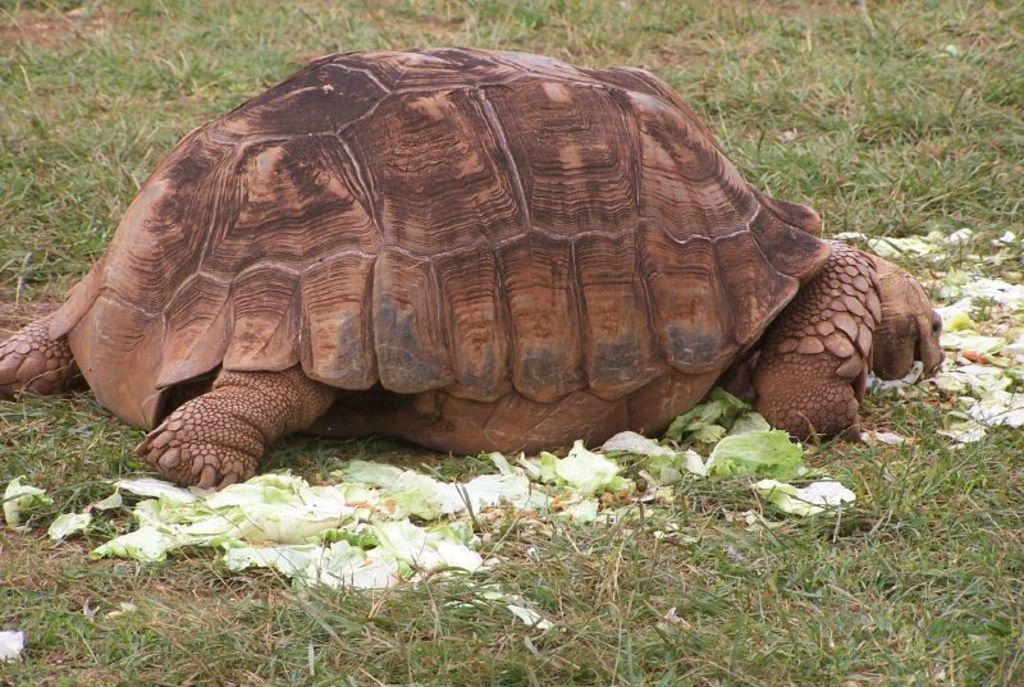Can you describe this image briefly? In this image there is a tortoise on the ground. There is grass on the ground. Beside the tortoise there is cabbage. 